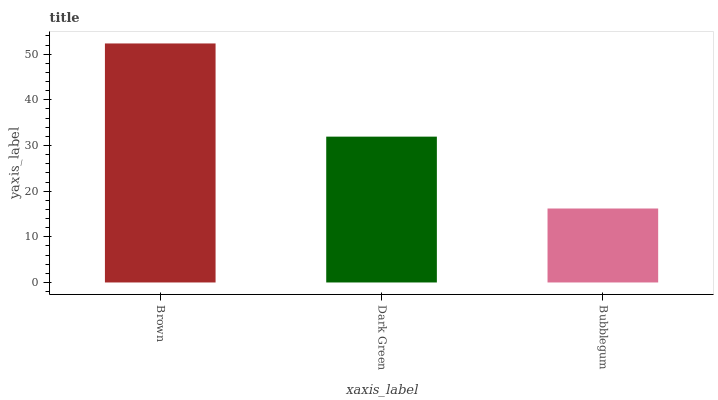Is Bubblegum the minimum?
Answer yes or no. Yes. Is Brown the maximum?
Answer yes or no. Yes. Is Dark Green the minimum?
Answer yes or no. No. Is Dark Green the maximum?
Answer yes or no. No. Is Brown greater than Dark Green?
Answer yes or no. Yes. Is Dark Green less than Brown?
Answer yes or no. Yes. Is Dark Green greater than Brown?
Answer yes or no. No. Is Brown less than Dark Green?
Answer yes or no. No. Is Dark Green the high median?
Answer yes or no. Yes. Is Dark Green the low median?
Answer yes or no. Yes. Is Bubblegum the high median?
Answer yes or no. No. Is Brown the low median?
Answer yes or no. No. 